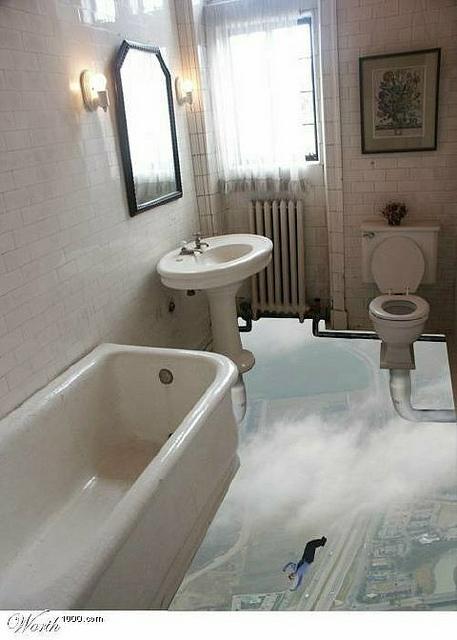Is this a room in a house?
Answer briefly. Yes. Does this bathroom make sense?
Be succinct. No. Does this bathroom have a floor?
Quick response, please. No. 